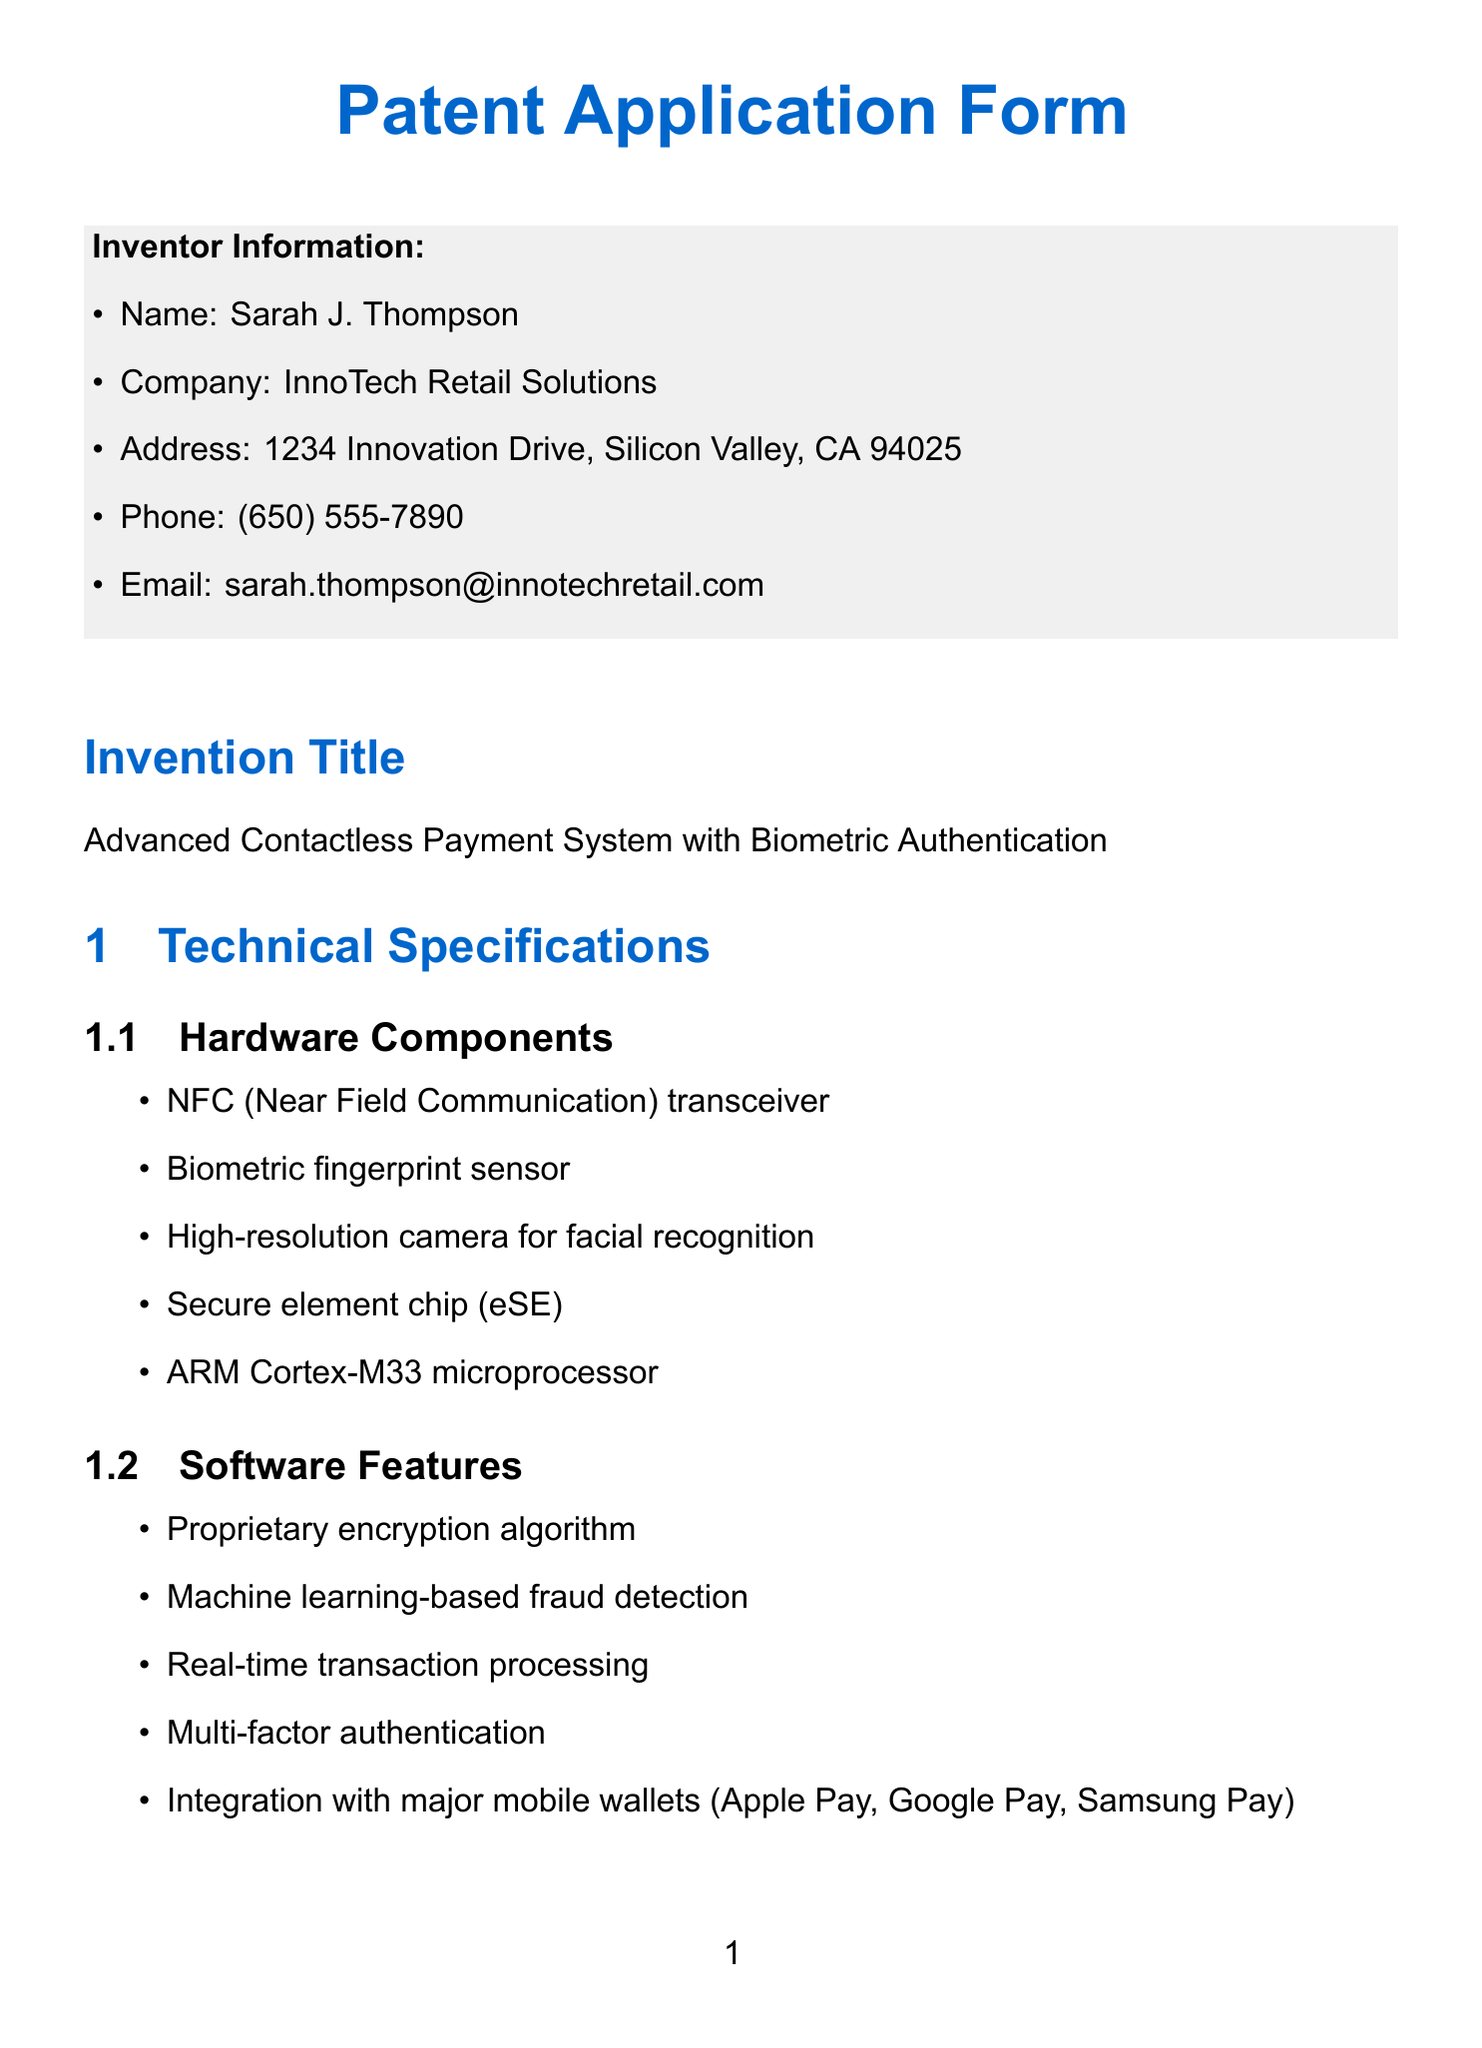What is the inventor's name? The inventor's name is found in the Inventor Information section of the document.
Answer: Sarah J. Thompson What is the title of the invention? The title of the invention is stated at the beginning of the Patent Application Form.
Answer: Advanced Contactless Payment System with Biometric Authentication How many hardware components are listed? The number of hardware components can be counted in the Technical Specifications section.
Answer: 5 Which microprocessor is used in the hardware? The specific microprocessor used is detailed under Hardware Components.
Answer: ARM Cortex-M33 microprocessor What two biometric methods are mentioned as unique features? The unique features include specific biometric methods under Unique Features section.
Answer: fingerprint and facial recognition What is one of the security measures listed? The security measures can be found in the Technical Specifications section.
Answer: Tokenization of payment data How many market applications are listed? The number of market applications can be counted in the Market Applications section.
Answer: 5 Which company is listed as a potential licensee? One potential licensee is stated in the Potential Licensees section of the document.
Answer: Visa Inc What is the relevant experience of the inventor? The relevant experience is mentioned in the Inventor Background section and is a single descriptive phrase.
Answer: 25 years in retail technology innovation What is the patent number of the first prior art? The first prior art's patent number is located in the Prior Art section of the document.
Answer: US10504100B2 